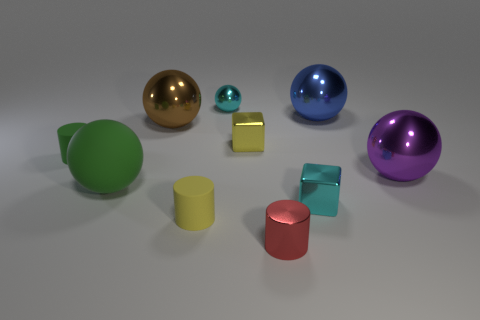Subtract all tiny balls. How many balls are left? 4 Subtract all cyan balls. How many balls are left? 4 Subtract all yellow balls. Subtract all gray cubes. How many balls are left? 5 Subtract all cylinders. How many objects are left? 7 Add 5 big spheres. How many big spheres are left? 9 Add 2 tiny blue shiny balls. How many tiny blue shiny balls exist? 2 Subtract 0 red spheres. How many objects are left? 10 Subtract all yellow things. Subtract all small metallic objects. How many objects are left? 4 